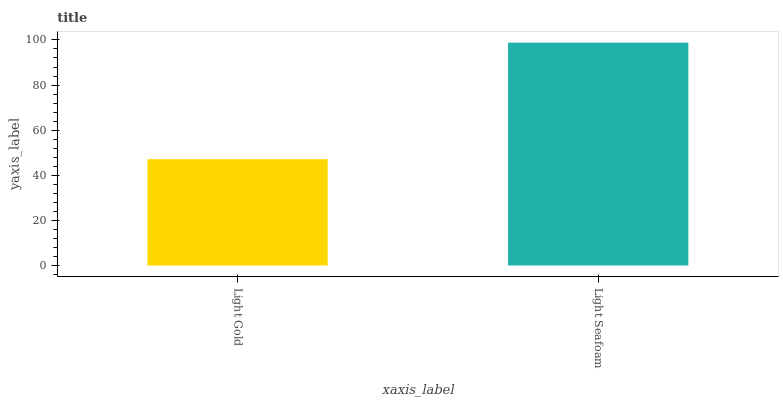Is Light Gold the minimum?
Answer yes or no. Yes. Is Light Seafoam the maximum?
Answer yes or no. Yes. Is Light Seafoam the minimum?
Answer yes or no. No. Is Light Seafoam greater than Light Gold?
Answer yes or no. Yes. Is Light Gold less than Light Seafoam?
Answer yes or no. Yes. Is Light Gold greater than Light Seafoam?
Answer yes or no. No. Is Light Seafoam less than Light Gold?
Answer yes or no. No. Is Light Seafoam the high median?
Answer yes or no. Yes. Is Light Gold the low median?
Answer yes or no. Yes. Is Light Gold the high median?
Answer yes or no. No. Is Light Seafoam the low median?
Answer yes or no. No. 